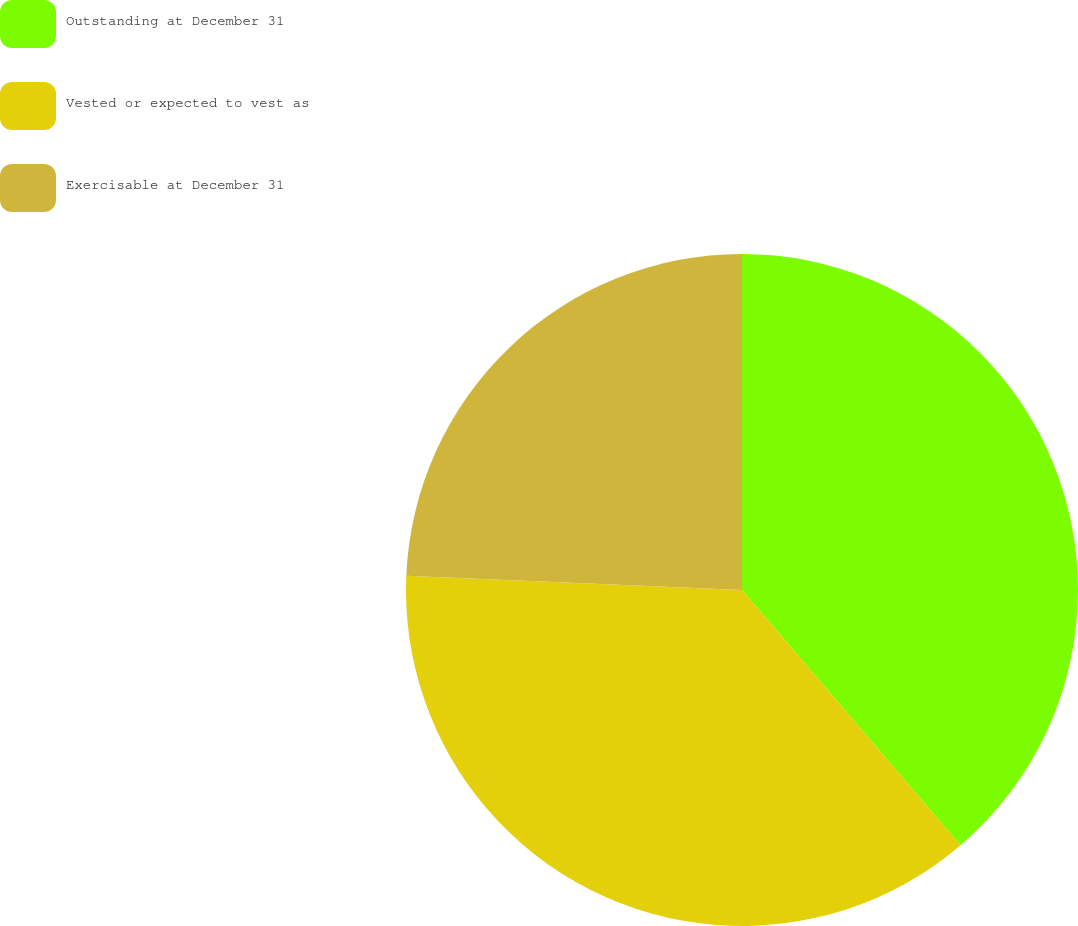<chart> <loc_0><loc_0><loc_500><loc_500><pie_chart><fcel>Outstanding at December 31<fcel>Vested or expected to vest as<fcel>Exercisable at December 31<nl><fcel>38.73%<fcel>36.95%<fcel>24.32%<nl></chart> 